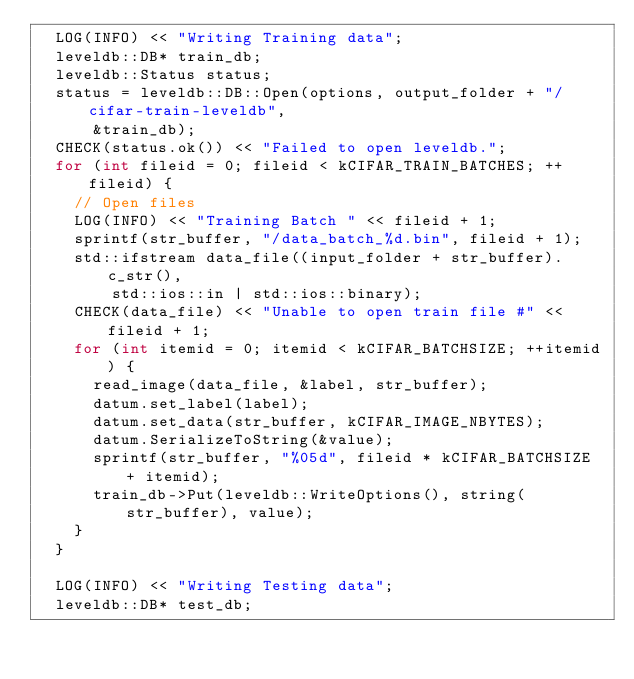<code> <loc_0><loc_0><loc_500><loc_500><_C++_>  LOG(INFO) << "Writing Training data";
  leveldb::DB* train_db;
  leveldb::Status status;
  status = leveldb::DB::Open(options, output_folder + "/cifar-train-leveldb",
      &train_db);
  CHECK(status.ok()) << "Failed to open leveldb.";
  for (int fileid = 0; fileid < kCIFAR_TRAIN_BATCHES; ++fileid) {
    // Open files
    LOG(INFO) << "Training Batch " << fileid + 1;
    sprintf(str_buffer, "/data_batch_%d.bin", fileid + 1);
    std::ifstream data_file((input_folder + str_buffer).c_str(),
        std::ios::in | std::ios::binary);
    CHECK(data_file) << "Unable to open train file #" << fileid + 1;
    for (int itemid = 0; itemid < kCIFAR_BATCHSIZE; ++itemid) {
      read_image(data_file, &label, str_buffer);
      datum.set_label(label);
      datum.set_data(str_buffer, kCIFAR_IMAGE_NBYTES);
      datum.SerializeToString(&value);
      sprintf(str_buffer, "%05d", fileid * kCIFAR_BATCHSIZE + itemid);
      train_db->Put(leveldb::WriteOptions(), string(str_buffer), value);
    }
  }

  LOG(INFO) << "Writing Testing data";
  leveldb::DB* test_db;</code> 